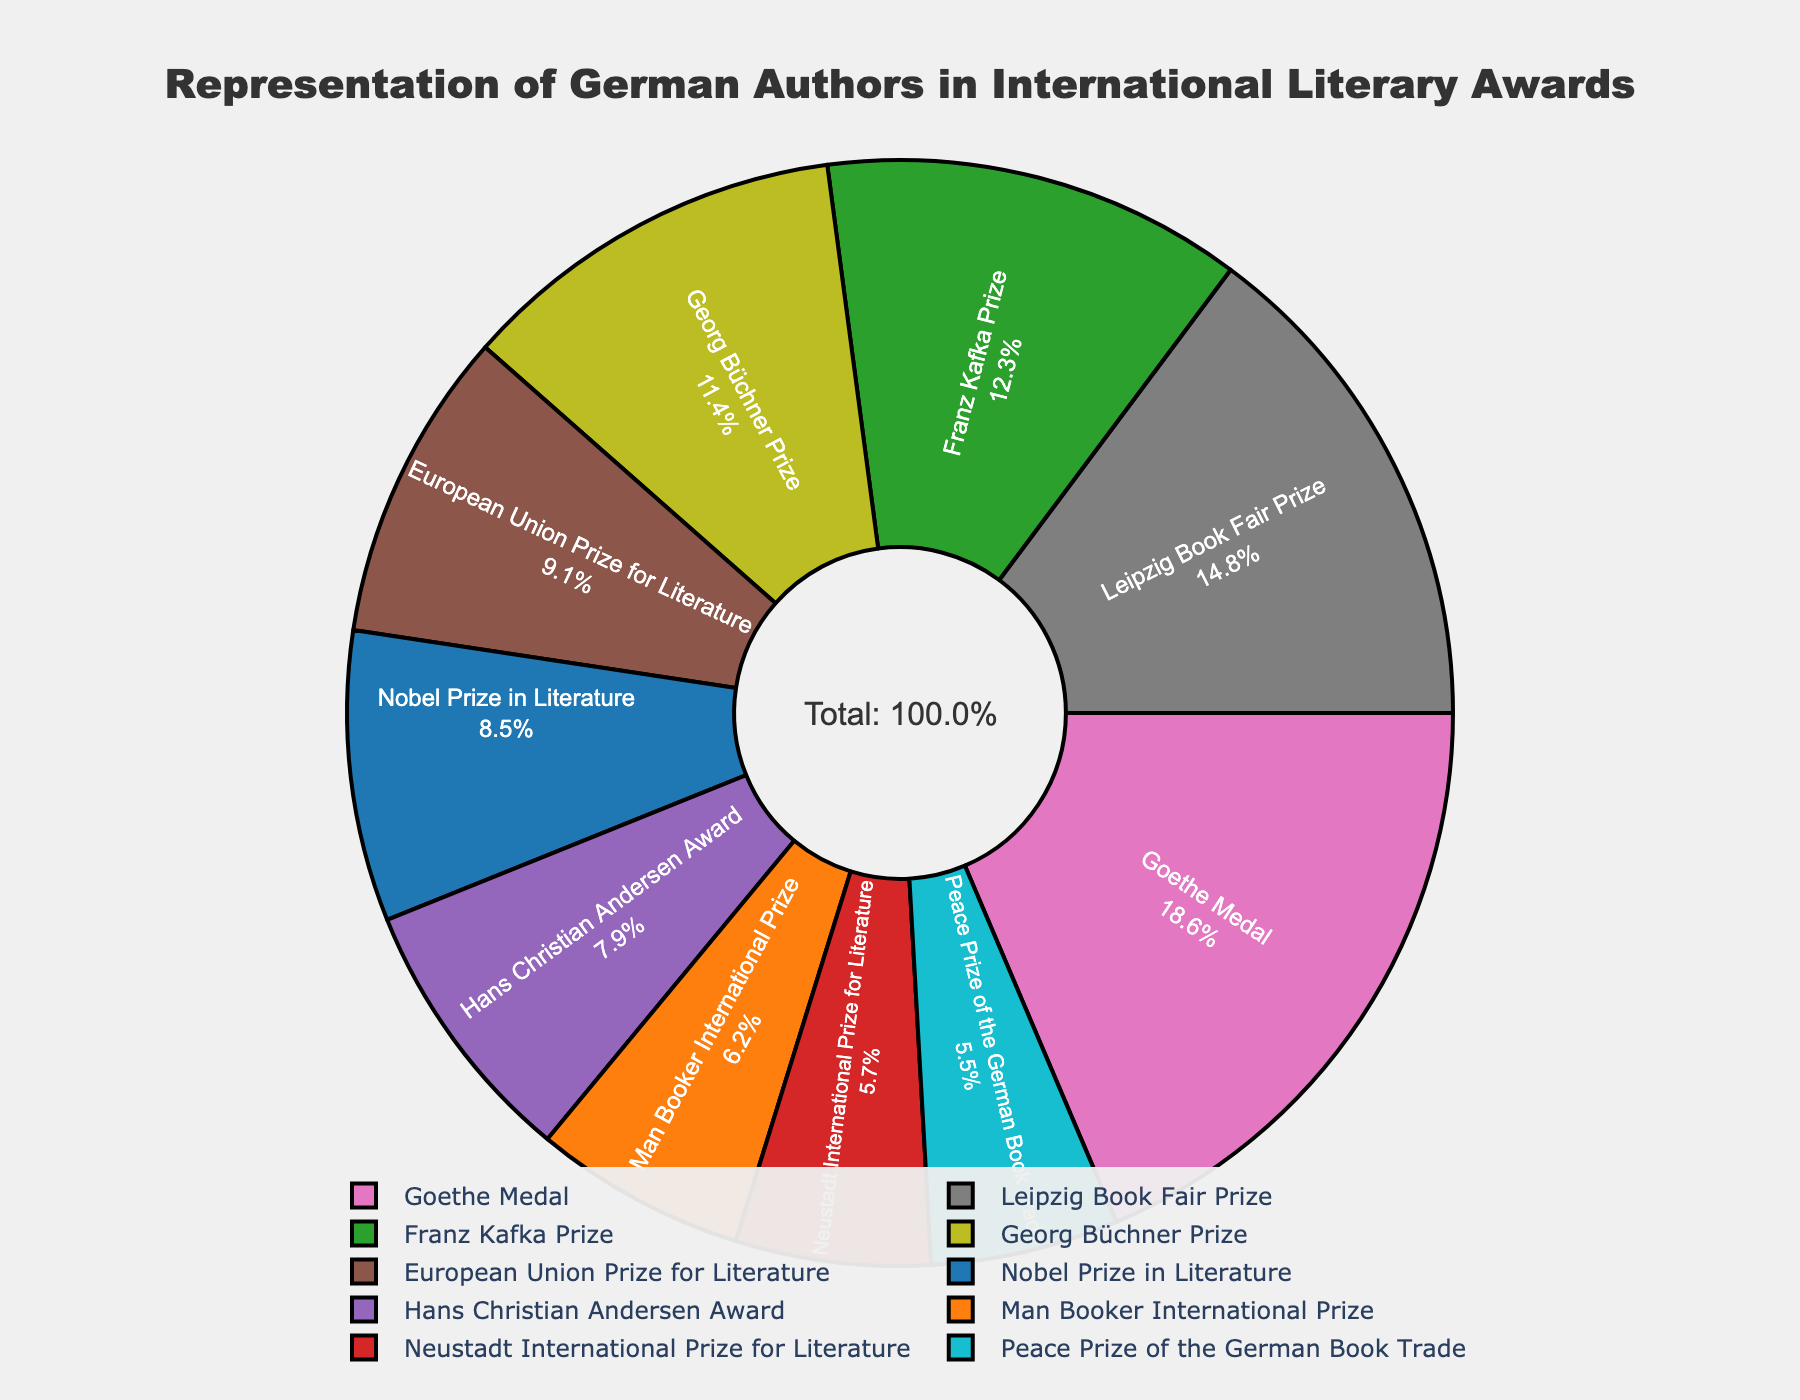Which award has the largest representation of German authors in international literary awards? The Goethe Medal has the largest representation, which occupies the biggest portion of the pie chart.
Answer: Goethe Medal Which two awards combined have the largest representation and what is their combined percentage? The Goethe Medal and the Leipzig Book Fair Prize combined have the largest representation. The Goethe Medal is 18.6% and the Leipzig Book Fair Prize is 14.8%, giving a total of 18.6% + 14.8% = 33.4%.
Answer: 33.4% What is the difference in representation between the Nobel Prize in Literature and the Georg Büchner Prize? The Nobel Prize in Literature represents 8.5% and the Georg Büchner Prize represents 11.4%. The difference is 11.4% - 8.5% = 2.9%.
Answer: 2.9% Which award has the smallest representation of German authors? The Peace Prize of the German Book Trade has the smallest representation, as it occupies the smallest portion of the pie chart.
Answer: Peace Prize of the German Book Trade Are German authors more represented in the Franz Kafka Prize or the Nobel Prize in Literature? German authors have a larger representation in the Franz Kafka Prize (12.3%) than in the Nobel Prize in Literature (8.5%).
Answer: Franz Kafka Prize What is the combined representation of awards with less than 10% each? Awards with less than 10% representation are: Nobel Prize in Literature (8.5%), Man Booker International Prize (6.2%), Neustadt International Prize for Literature (5.7%), Hans Christian Andersen Award (7.9%), and Peace Prize of the German Book Trade (5.5%). The combined percentage is 8.5% + 6.2% + 5.7% + 7.9% + 5.5% = 33.8%.
Answer: 33.8% Does the European Union Prize for Literature represent more German authors than the Hans Christian Andersen Award? Yes, the European Union Prize for Literature represents 9.1% of German authors, while the Hans Christian Andersen Award represents 7.9%.
Answer: Yes If you combined the percentage shares of the Nobel Prize in Literature and the Man Booker International Prize, would it surpass the Goethe Medal's share? The Nobel Prize in Literature is 8.5% and the Man Booker International Prize is 6.2%, giving a combined total of 8.5% + 6.2% = 14.7%, which is less than the Goethe Medal's 18.6%.
Answer: No What percentage is covered by the top 3 awards in terms of German authors' representation? The top 3 awards are Goethe Medal (18.6%), Leipzig Book Fair Prize (14.8%), and Franz Kafka Prize (12.3%). Their combined percentage is 18.6% + 14.8% + 12.3% = 45.7%.
Answer: 45.7% What is the median percentage represented by the listed awards? To find the median, first list all percentages in ascending order: 5.5%, 5.7%, 6.2%, 7.9%, 8.5%, 9.1%, 11.4%, 12.3%, 14.8%, 18.6%. The median is the average of the 5th and 6th values, (8.5% + 9.1%) / 2 = 17.6 / 2 = 8.8%.
Answer: 8.8% 